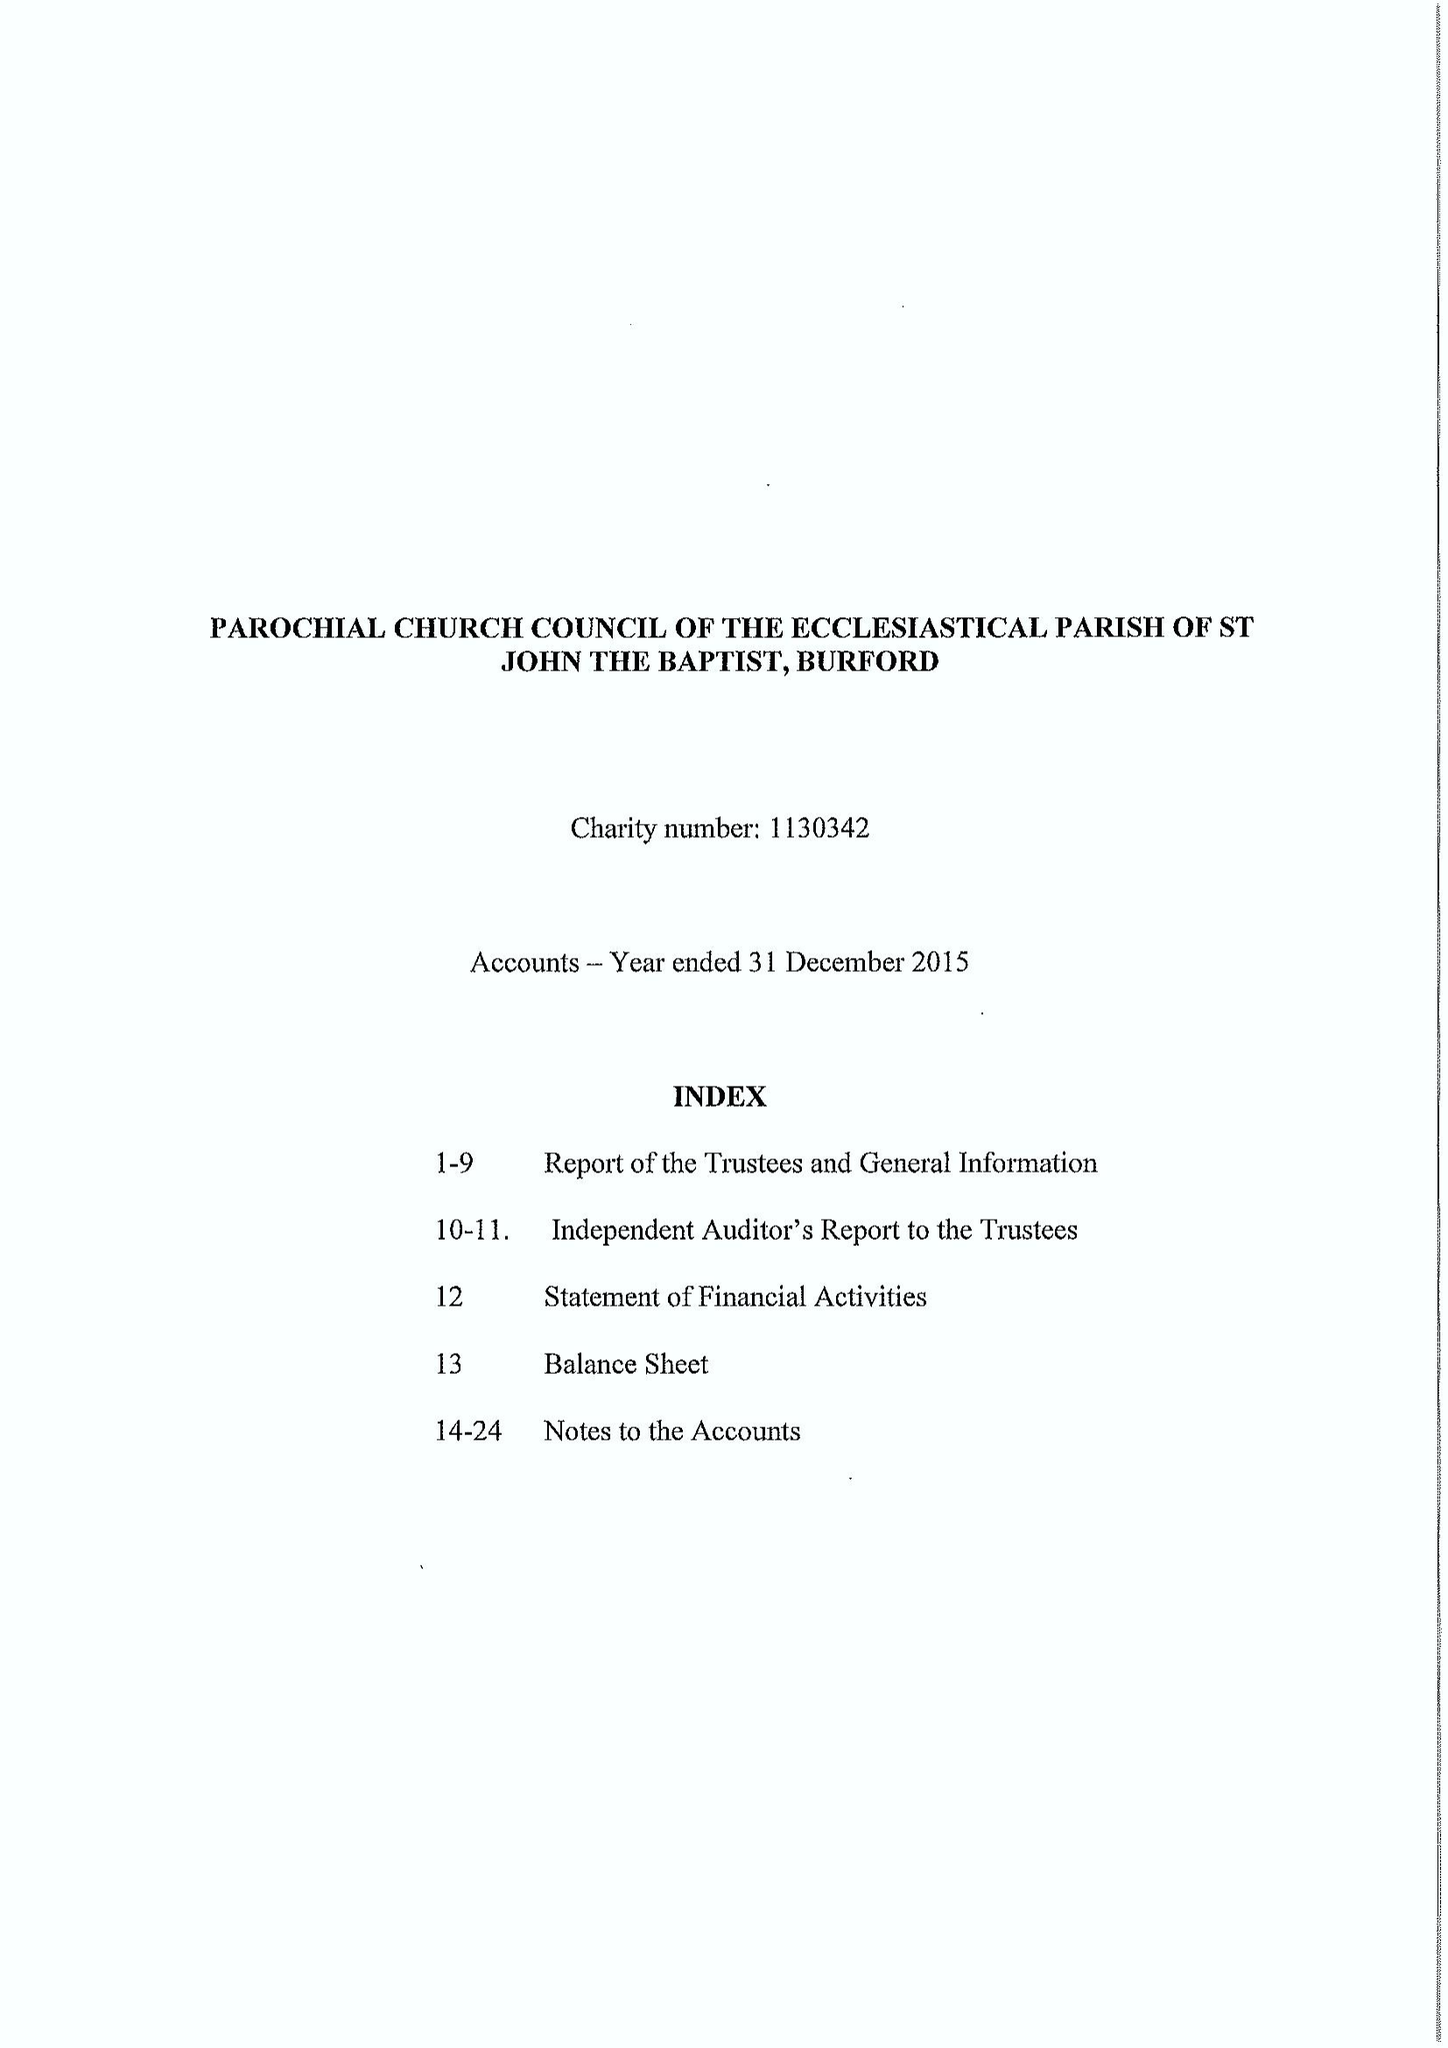What is the value for the charity_number?
Answer the question using a single word or phrase. 1130342 